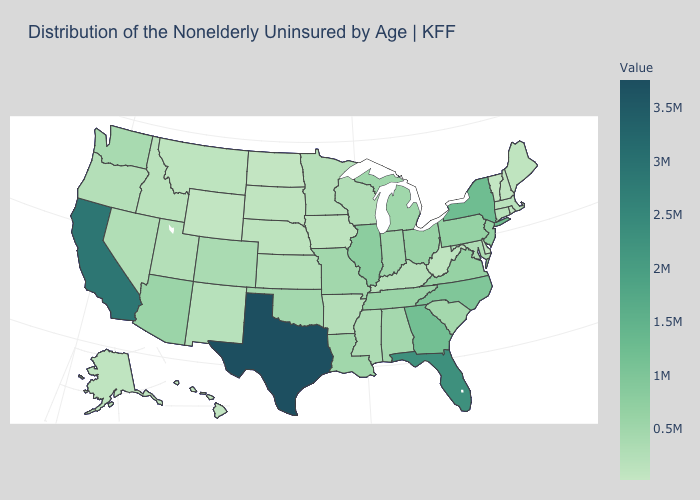Is the legend a continuous bar?
Short answer required. Yes. Among the states that border Connecticut , does Massachusetts have the highest value?
Answer briefly. No. Among the states that border New York , which have the lowest value?
Be succinct. Vermont. Is the legend a continuous bar?
Be succinct. Yes. 